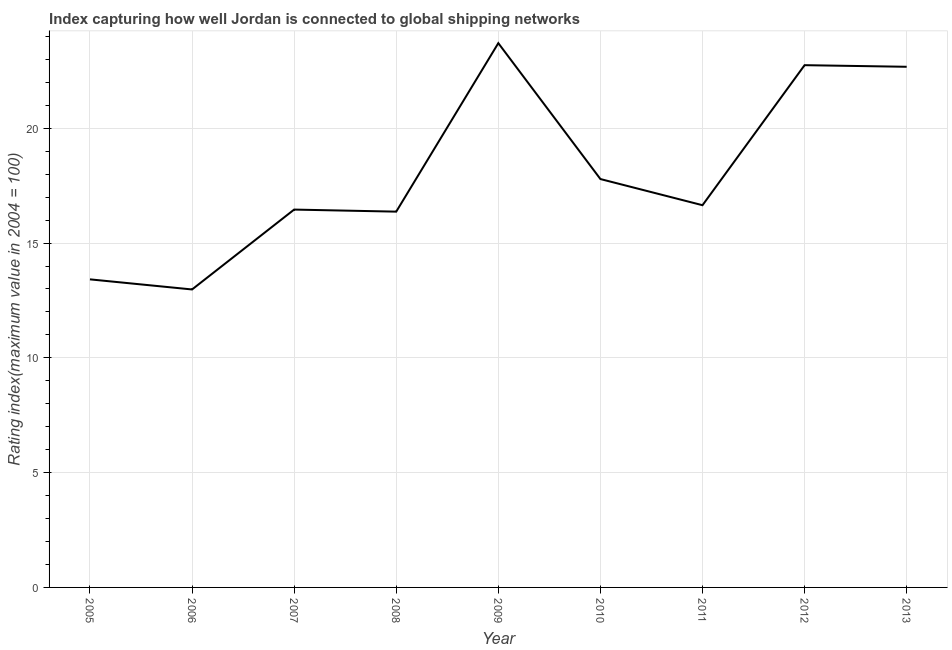What is the liner shipping connectivity index in 2013?
Your response must be concise. 22.68. Across all years, what is the maximum liner shipping connectivity index?
Your response must be concise. 23.71. Across all years, what is the minimum liner shipping connectivity index?
Your answer should be very brief. 12.98. What is the sum of the liner shipping connectivity index?
Provide a succinct answer. 162.81. What is the difference between the liner shipping connectivity index in 2008 and 2009?
Offer a terse response. -7.34. What is the average liner shipping connectivity index per year?
Ensure brevity in your answer.  18.09. What is the median liner shipping connectivity index?
Provide a succinct answer. 16.65. Do a majority of the years between 2012 and 2008 (inclusive) have liner shipping connectivity index greater than 19 ?
Offer a terse response. Yes. What is the ratio of the liner shipping connectivity index in 2011 to that in 2012?
Give a very brief answer. 0.73. Is the difference between the liner shipping connectivity index in 2006 and 2007 greater than the difference between any two years?
Ensure brevity in your answer.  No. What is the difference between the highest and the second highest liner shipping connectivity index?
Your answer should be very brief. 0.96. Is the sum of the liner shipping connectivity index in 2006 and 2012 greater than the maximum liner shipping connectivity index across all years?
Make the answer very short. Yes. What is the difference between the highest and the lowest liner shipping connectivity index?
Your answer should be very brief. 10.73. Does the liner shipping connectivity index monotonically increase over the years?
Make the answer very short. No. How many lines are there?
Give a very brief answer. 1. Does the graph contain grids?
Your answer should be very brief. Yes. What is the title of the graph?
Provide a short and direct response. Index capturing how well Jordan is connected to global shipping networks. What is the label or title of the X-axis?
Your answer should be very brief. Year. What is the label or title of the Y-axis?
Keep it short and to the point. Rating index(maximum value in 2004 = 100). What is the Rating index(maximum value in 2004 = 100) in 2005?
Your answer should be compact. 13.42. What is the Rating index(maximum value in 2004 = 100) in 2006?
Provide a short and direct response. 12.98. What is the Rating index(maximum value in 2004 = 100) in 2007?
Offer a terse response. 16.46. What is the Rating index(maximum value in 2004 = 100) in 2008?
Ensure brevity in your answer.  16.37. What is the Rating index(maximum value in 2004 = 100) in 2009?
Provide a succinct answer. 23.71. What is the Rating index(maximum value in 2004 = 100) in 2010?
Your answer should be very brief. 17.79. What is the Rating index(maximum value in 2004 = 100) in 2011?
Keep it short and to the point. 16.65. What is the Rating index(maximum value in 2004 = 100) of 2012?
Your response must be concise. 22.75. What is the Rating index(maximum value in 2004 = 100) of 2013?
Provide a short and direct response. 22.68. What is the difference between the Rating index(maximum value in 2004 = 100) in 2005 and 2006?
Your response must be concise. 0.44. What is the difference between the Rating index(maximum value in 2004 = 100) in 2005 and 2007?
Offer a very short reply. -3.04. What is the difference between the Rating index(maximum value in 2004 = 100) in 2005 and 2008?
Ensure brevity in your answer.  -2.95. What is the difference between the Rating index(maximum value in 2004 = 100) in 2005 and 2009?
Your response must be concise. -10.29. What is the difference between the Rating index(maximum value in 2004 = 100) in 2005 and 2010?
Provide a short and direct response. -4.37. What is the difference between the Rating index(maximum value in 2004 = 100) in 2005 and 2011?
Provide a short and direct response. -3.23. What is the difference between the Rating index(maximum value in 2004 = 100) in 2005 and 2012?
Your answer should be compact. -9.33. What is the difference between the Rating index(maximum value in 2004 = 100) in 2005 and 2013?
Offer a terse response. -9.26. What is the difference between the Rating index(maximum value in 2004 = 100) in 2006 and 2007?
Keep it short and to the point. -3.48. What is the difference between the Rating index(maximum value in 2004 = 100) in 2006 and 2008?
Make the answer very short. -3.39. What is the difference between the Rating index(maximum value in 2004 = 100) in 2006 and 2009?
Make the answer very short. -10.73. What is the difference between the Rating index(maximum value in 2004 = 100) in 2006 and 2010?
Make the answer very short. -4.81. What is the difference between the Rating index(maximum value in 2004 = 100) in 2006 and 2011?
Make the answer very short. -3.67. What is the difference between the Rating index(maximum value in 2004 = 100) in 2006 and 2012?
Your answer should be compact. -9.77. What is the difference between the Rating index(maximum value in 2004 = 100) in 2007 and 2008?
Provide a short and direct response. 0.09. What is the difference between the Rating index(maximum value in 2004 = 100) in 2007 and 2009?
Give a very brief answer. -7.25. What is the difference between the Rating index(maximum value in 2004 = 100) in 2007 and 2010?
Offer a very short reply. -1.33. What is the difference between the Rating index(maximum value in 2004 = 100) in 2007 and 2011?
Make the answer very short. -0.19. What is the difference between the Rating index(maximum value in 2004 = 100) in 2007 and 2012?
Your answer should be very brief. -6.29. What is the difference between the Rating index(maximum value in 2004 = 100) in 2007 and 2013?
Ensure brevity in your answer.  -6.22. What is the difference between the Rating index(maximum value in 2004 = 100) in 2008 and 2009?
Make the answer very short. -7.34. What is the difference between the Rating index(maximum value in 2004 = 100) in 2008 and 2010?
Keep it short and to the point. -1.42. What is the difference between the Rating index(maximum value in 2004 = 100) in 2008 and 2011?
Make the answer very short. -0.28. What is the difference between the Rating index(maximum value in 2004 = 100) in 2008 and 2012?
Ensure brevity in your answer.  -6.38. What is the difference between the Rating index(maximum value in 2004 = 100) in 2008 and 2013?
Give a very brief answer. -6.31. What is the difference between the Rating index(maximum value in 2004 = 100) in 2009 and 2010?
Your answer should be very brief. 5.92. What is the difference between the Rating index(maximum value in 2004 = 100) in 2009 and 2011?
Your answer should be compact. 7.06. What is the difference between the Rating index(maximum value in 2004 = 100) in 2010 and 2011?
Provide a succinct answer. 1.14. What is the difference between the Rating index(maximum value in 2004 = 100) in 2010 and 2012?
Provide a short and direct response. -4.96. What is the difference between the Rating index(maximum value in 2004 = 100) in 2010 and 2013?
Ensure brevity in your answer.  -4.89. What is the difference between the Rating index(maximum value in 2004 = 100) in 2011 and 2013?
Your response must be concise. -6.03. What is the difference between the Rating index(maximum value in 2004 = 100) in 2012 and 2013?
Ensure brevity in your answer.  0.07. What is the ratio of the Rating index(maximum value in 2004 = 100) in 2005 to that in 2006?
Ensure brevity in your answer.  1.03. What is the ratio of the Rating index(maximum value in 2004 = 100) in 2005 to that in 2007?
Your response must be concise. 0.81. What is the ratio of the Rating index(maximum value in 2004 = 100) in 2005 to that in 2008?
Provide a short and direct response. 0.82. What is the ratio of the Rating index(maximum value in 2004 = 100) in 2005 to that in 2009?
Your response must be concise. 0.57. What is the ratio of the Rating index(maximum value in 2004 = 100) in 2005 to that in 2010?
Your answer should be very brief. 0.75. What is the ratio of the Rating index(maximum value in 2004 = 100) in 2005 to that in 2011?
Make the answer very short. 0.81. What is the ratio of the Rating index(maximum value in 2004 = 100) in 2005 to that in 2012?
Your response must be concise. 0.59. What is the ratio of the Rating index(maximum value in 2004 = 100) in 2005 to that in 2013?
Offer a very short reply. 0.59. What is the ratio of the Rating index(maximum value in 2004 = 100) in 2006 to that in 2007?
Your answer should be very brief. 0.79. What is the ratio of the Rating index(maximum value in 2004 = 100) in 2006 to that in 2008?
Offer a very short reply. 0.79. What is the ratio of the Rating index(maximum value in 2004 = 100) in 2006 to that in 2009?
Make the answer very short. 0.55. What is the ratio of the Rating index(maximum value in 2004 = 100) in 2006 to that in 2010?
Offer a very short reply. 0.73. What is the ratio of the Rating index(maximum value in 2004 = 100) in 2006 to that in 2011?
Provide a succinct answer. 0.78. What is the ratio of the Rating index(maximum value in 2004 = 100) in 2006 to that in 2012?
Offer a very short reply. 0.57. What is the ratio of the Rating index(maximum value in 2004 = 100) in 2006 to that in 2013?
Provide a succinct answer. 0.57. What is the ratio of the Rating index(maximum value in 2004 = 100) in 2007 to that in 2009?
Your answer should be compact. 0.69. What is the ratio of the Rating index(maximum value in 2004 = 100) in 2007 to that in 2010?
Make the answer very short. 0.93. What is the ratio of the Rating index(maximum value in 2004 = 100) in 2007 to that in 2011?
Give a very brief answer. 0.99. What is the ratio of the Rating index(maximum value in 2004 = 100) in 2007 to that in 2012?
Give a very brief answer. 0.72. What is the ratio of the Rating index(maximum value in 2004 = 100) in 2007 to that in 2013?
Give a very brief answer. 0.73. What is the ratio of the Rating index(maximum value in 2004 = 100) in 2008 to that in 2009?
Your response must be concise. 0.69. What is the ratio of the Rating index(maximum value in 2004 = 100) in 2008 to that in 2012?
Your answer should be compact. 0.72. What is the ratio of the Rating index(maximum value in 2004 = 100) in 2008 to that in 2013?
Give a very brief answer. 0.72. What is the ratio of the Rating index(maximum value in 2004 = 100) in 2009 to that in 2010?
Make the answer very short. 1.33. What is the ratio of the Rating index(maximum value in 2004 = 100) in 2009 to that in 2011?
Offer a terse response. 1.42. What is the ratio of the Rating index(maximum value in 2004 = 100) in 2009 to that in 2012?
Provide a short and direct response. 1.04. What is the ratio of the Rating index(maximum value in 2004 = 100) in 2009 to that in 2013?
Give a very brief answer. 1.04. What is the ratio of the Rating index(maximum value in 2004 = 100) in 2010 to that in 2011?
Keep it short and to the point. 1.07. What is the ratio of the Rating index(maximum value in 2004 = 100) in 2010 to that in 2012?
Your answer should be compact. 0.78. What is the ratio of the Rating index(maximum value in 2004 = 100) in 2010 to that in 2013?
Your response must be concise. 0.78. What is the ratio of the Rating index(maximum value in 2004 = 100) in 2011 to that in 2012?
Make the answer very short. 0.73. What is the ratio of the Rating index(maximum value in 2004 = 100) in 2011 to that in 2013?
Ensure brevity in your answer.  0.73. What is the ratio of the Rating index(maximum value in 2004 = 100) in 2012 to that in 2013?
Keep it short and to the point. 1. 